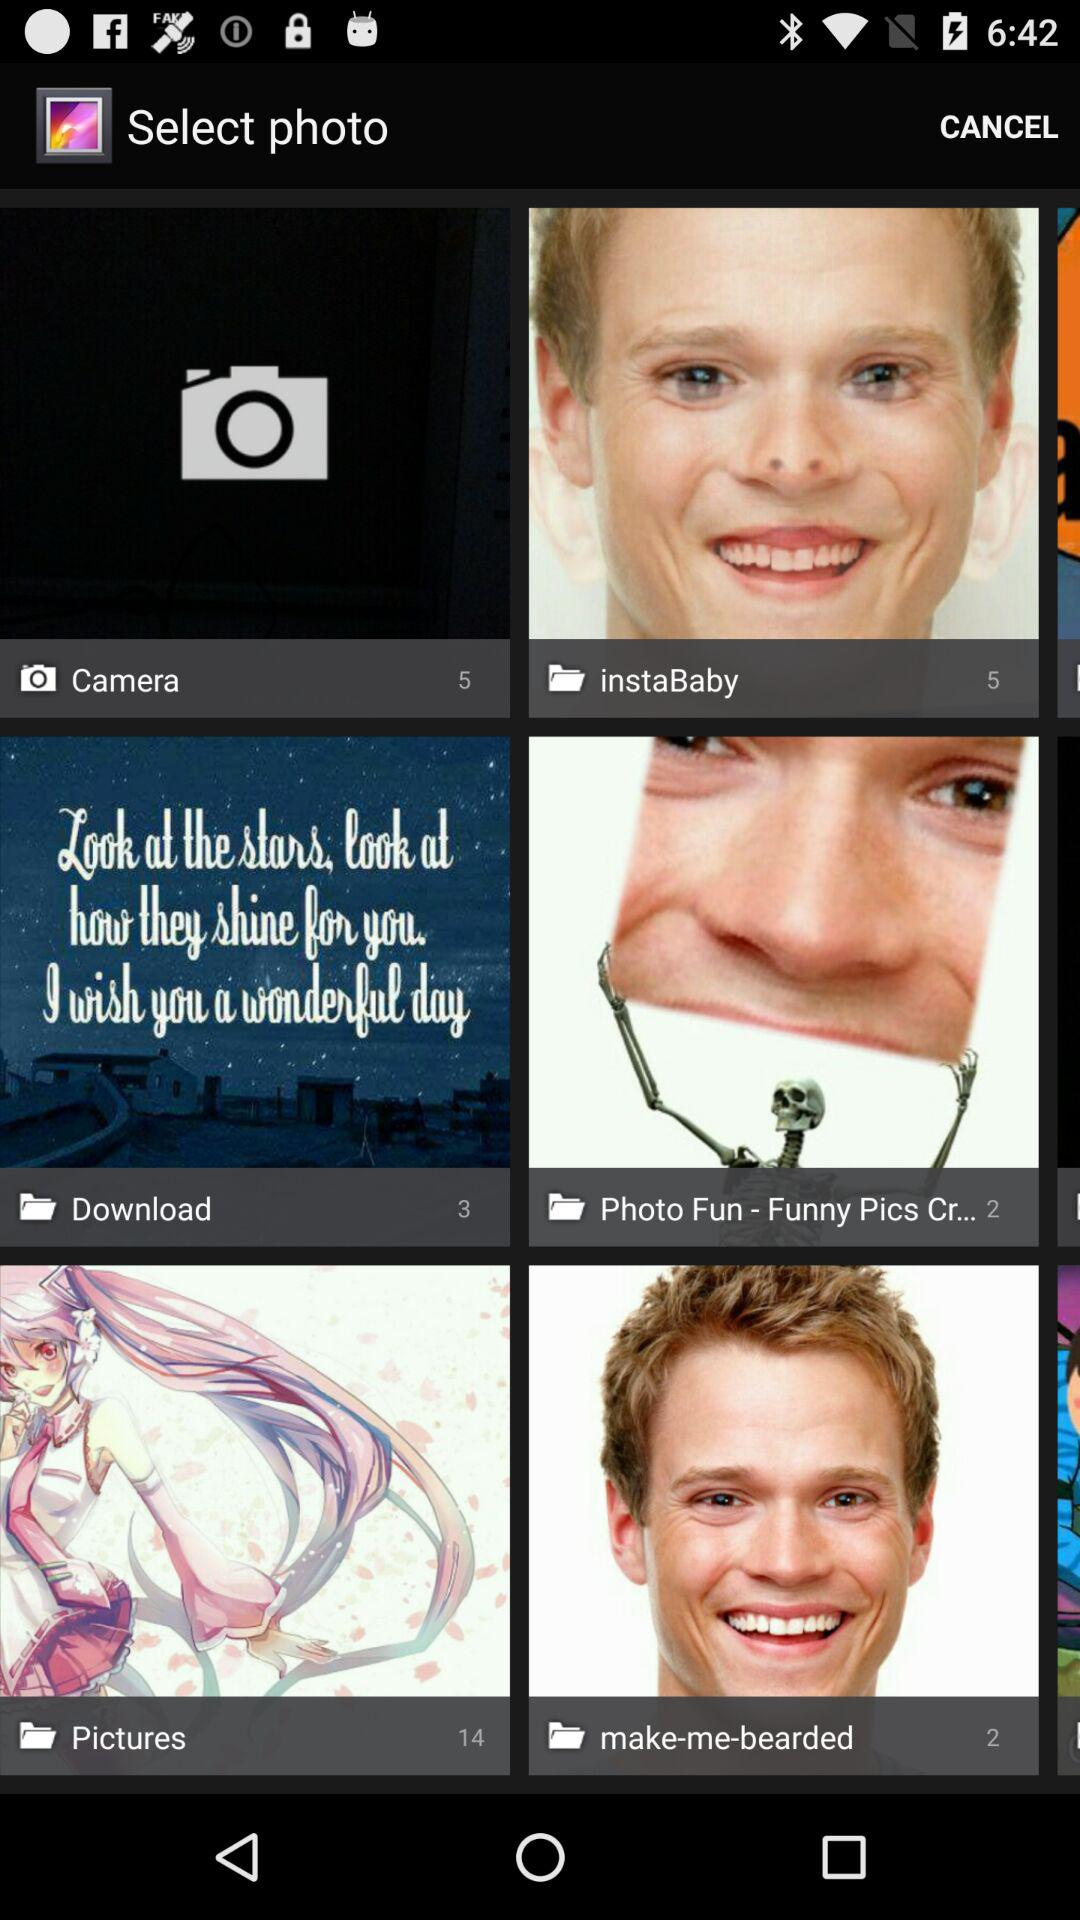What is the number of photos in the camera? The number of photos is 5. 